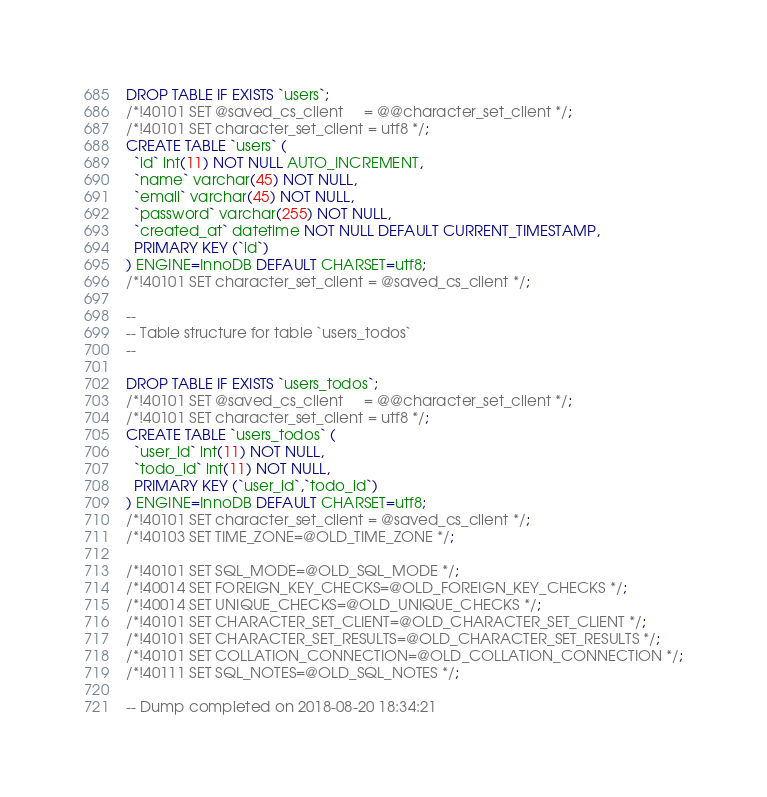Convert code to text. <code><loc_0><loc_0><loc_500><loc_500><_SQL_>
DROP TABLE IF EXISTS `users`;
/*!40101 SET @saved_cs_client     = @@character_set_client */;
/*!40101 SET character_set_client = utf8 */;
CREATE TABLE `users` (
  `id` int(11) NOT NULL AUTO_INCREMENT,
  `name` varchar(45) NOT NULL,
  `email` varchar(45) NOT NULL,
  `password` varchar(255) NOT NULL,
  `created_at` datetime NOT NULL DEFAULT CURRENT_TIMESTAMP,
  PRIMARY KEY (`id`)
) ENGINE=InnoDB DEFAULT CHARSET=utf8;
/*!40101 SET character_set_client = @saved_cs_client */;

--
-- Table structure for table `users_todos`
--

DROP TABLE IF EXISTS `users_todos`;
/*!40101 SET @saved_cs_client     = @@character_set_client */;
/*!40101 SET character_set_client = utf8 */;
CREATE TABLE `users_todos` (
  `user_id` int(11) NOT NULL,
  `todo_id` int(11) NOT NULL,
  PRIMARY KEY (`user_id`,`todo_id`)
) ENGINE=InnoDB DEFAULT CHARSET=utf8;
/*!40101 SET character_set_client = @saved_cs_client */;
/*!40103 SET TIME_ZONE=@OLD_TIME_ZONE */;

/*!40101 SET SQL_MODE=@OLD_SQL_MODE */;
/*!40014 SET FOREIGN_KEY_CHECKS=@OLD_FOREIGN_KEY_CHECKS */;
/*!40014 SET UNIQUE_CHECKS=@OLD_UNIQUE_CHECKS */;
/*!40101 SET CHARACTER_SET_CLIENT=@OLD_CHARACTER_SET_CLIENT */;
/*!40101 SET CHARACTER_SET_RESULTS=@OLD_CHARACTER_SET_RESULTS */;
/*!40101 SET COLLATION_CONNECTION=@OLD_COLLATION_CONNECTION */;
/*!40111 SET SQL_NOTES=@OLD_SQL_NOTES */;

-- Dump completed on 2018-08-20 18:34:21
</code> 